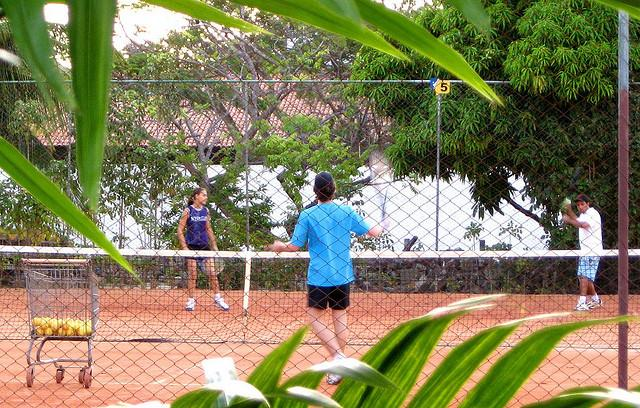What are the tennis balls in the cart for?

Choices:
A) selling
B) training
C) playing
D) gifting training 